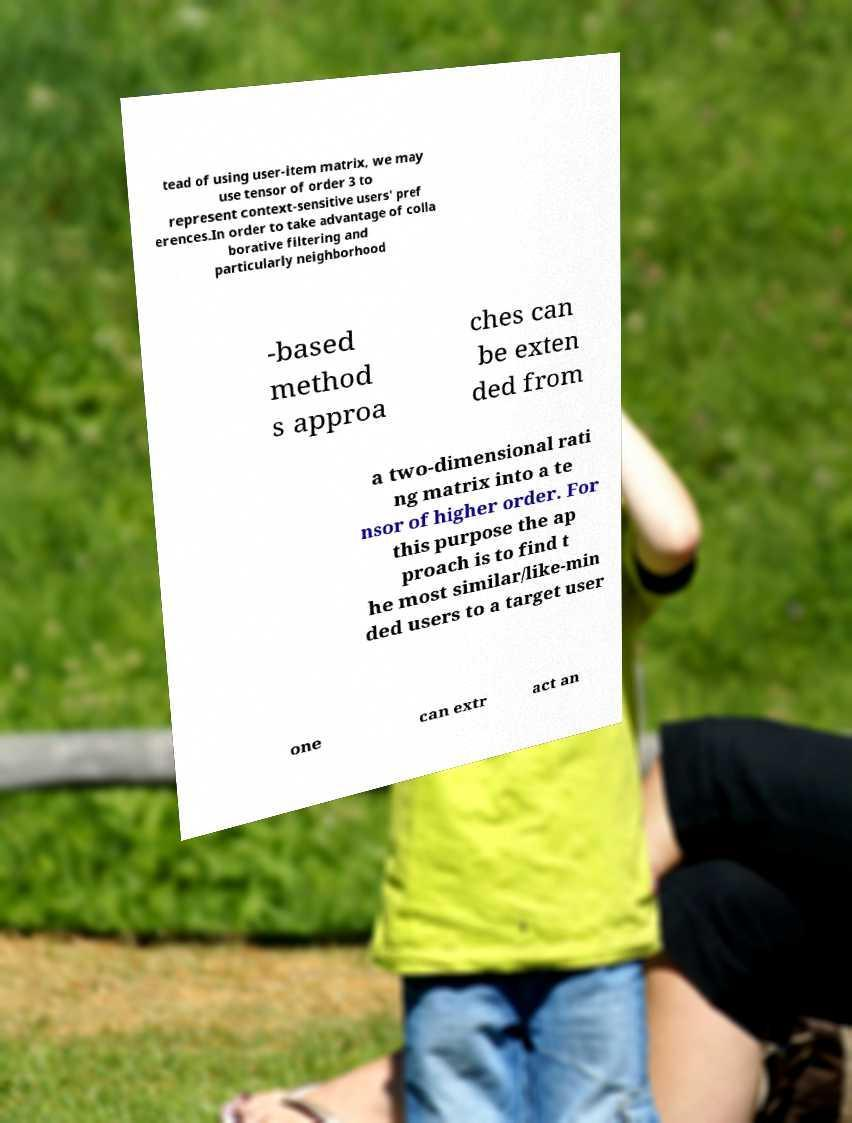Can you read and provide the text displayed in the image?This photo seems to have some interesting text. Can you extract and type it out for me? tead of using user-item matrix, we may use tensor of order 3 to represent context-sensitive users' pref erences.In order to take advantage of colla borative filtering and particularly neighborhood -based method s approa ches can be exten ded from a two-dimensional rati ng matrix into a te nsor of higher order. For this purpose the ap proach is to find t he most similar/like-min ded users to a target user one can extr act an 